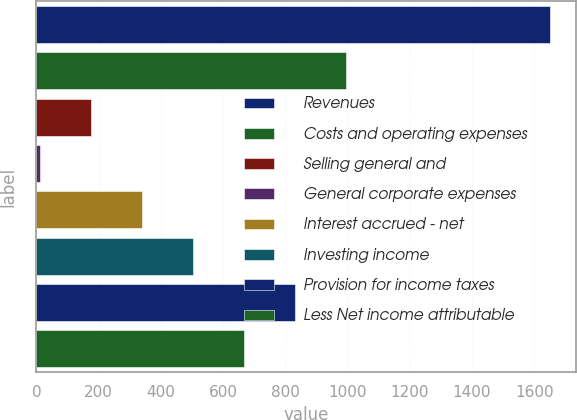Convert chart. <chart><loc_0><loc_0><loc_500><loc_500><bar_chart><fcel>Revenues<fcel>Costs and operating expenses<fcel>Selling general and<fcel>General corporate expenses<fcel>Interest accrued - net<fcel>Investing income<fcel>Provision for income taxes<fcel>Less Net income attributable<nl><fcel>1651<fcel>995.4<fcel>175.9<fcel>12<fcel>339.8<fcel>503.7<fcel>831.5<fcel>667.6<nl></chart> 